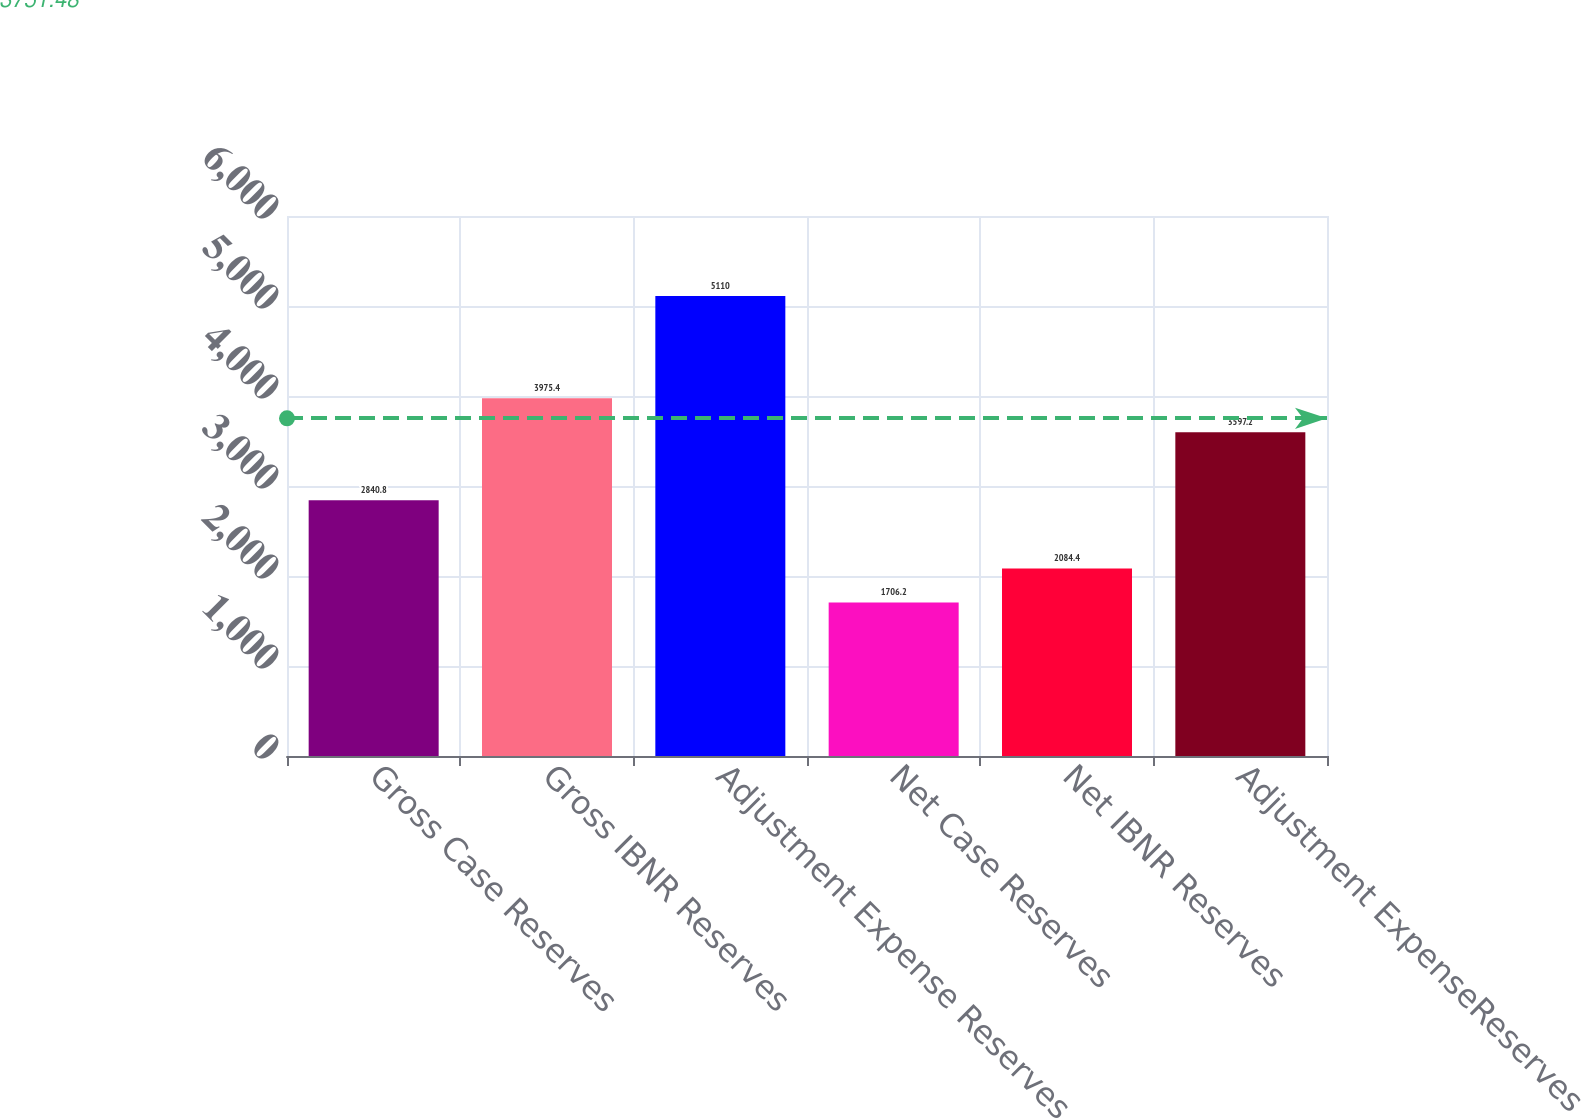Convert chart to OTSL. <chart><loc_0><loc_0><loc_500><loc_500><bar_chart><fcel>Gross Case Reserves<fcel>Gross IBNR Reserves<fcel>Adjustment Expense Reserves<fcel>Net Case Reserves<fcel>Net IBNR Reserves<fcel>Adjustment ExpenseReserves<nl><fcel>2840.8<fcel>3975.4<fcel>5110<fcel>1706.2<fcel>2084.4<fcel>3597.2<nl></chart> 